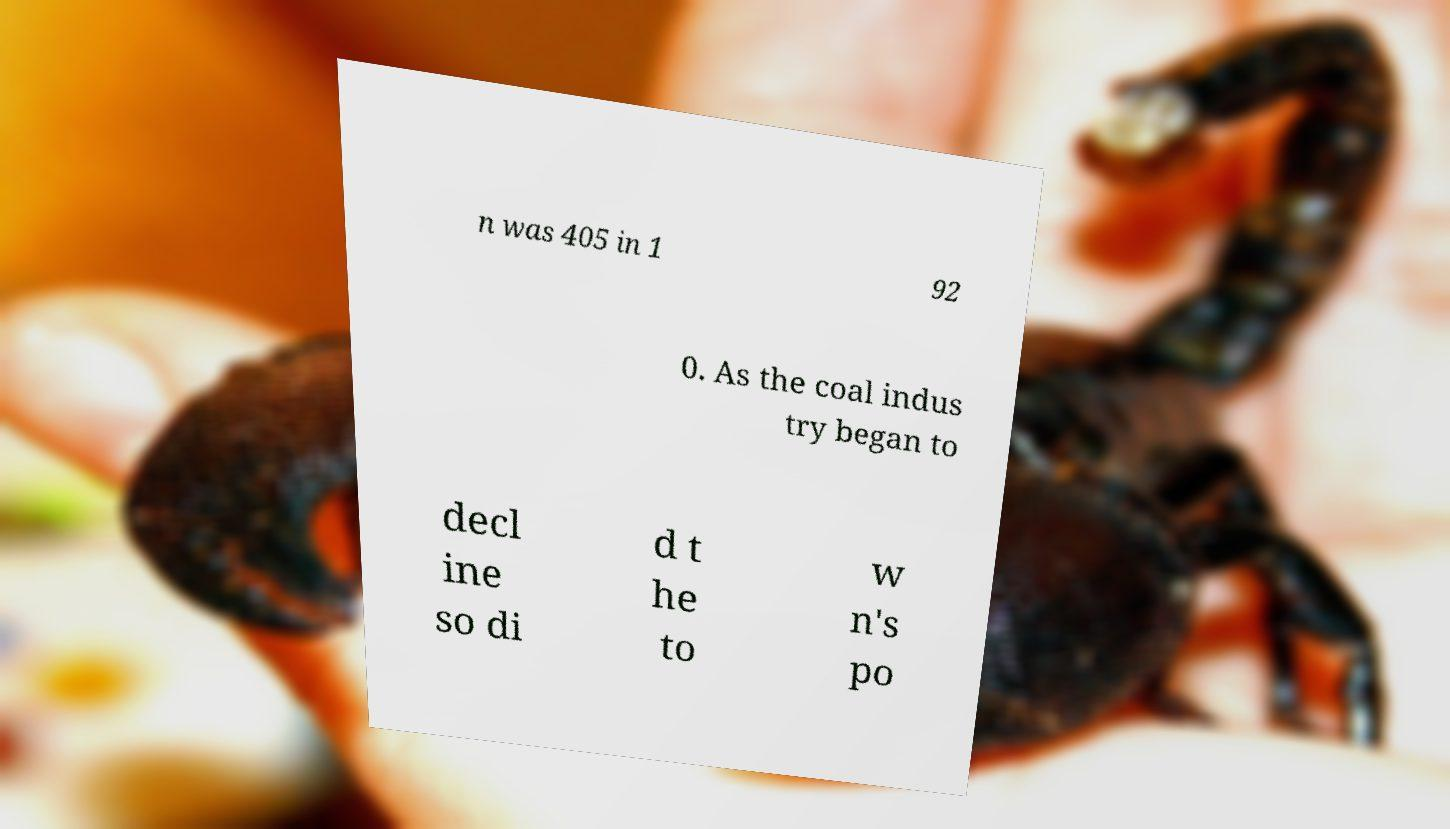There's text embedded in this image that I need extracted. Can you transcribe it verbatim? n was 405 in 1 92 0. As the coal indus try began to decl ine so di d t he to w n's po 